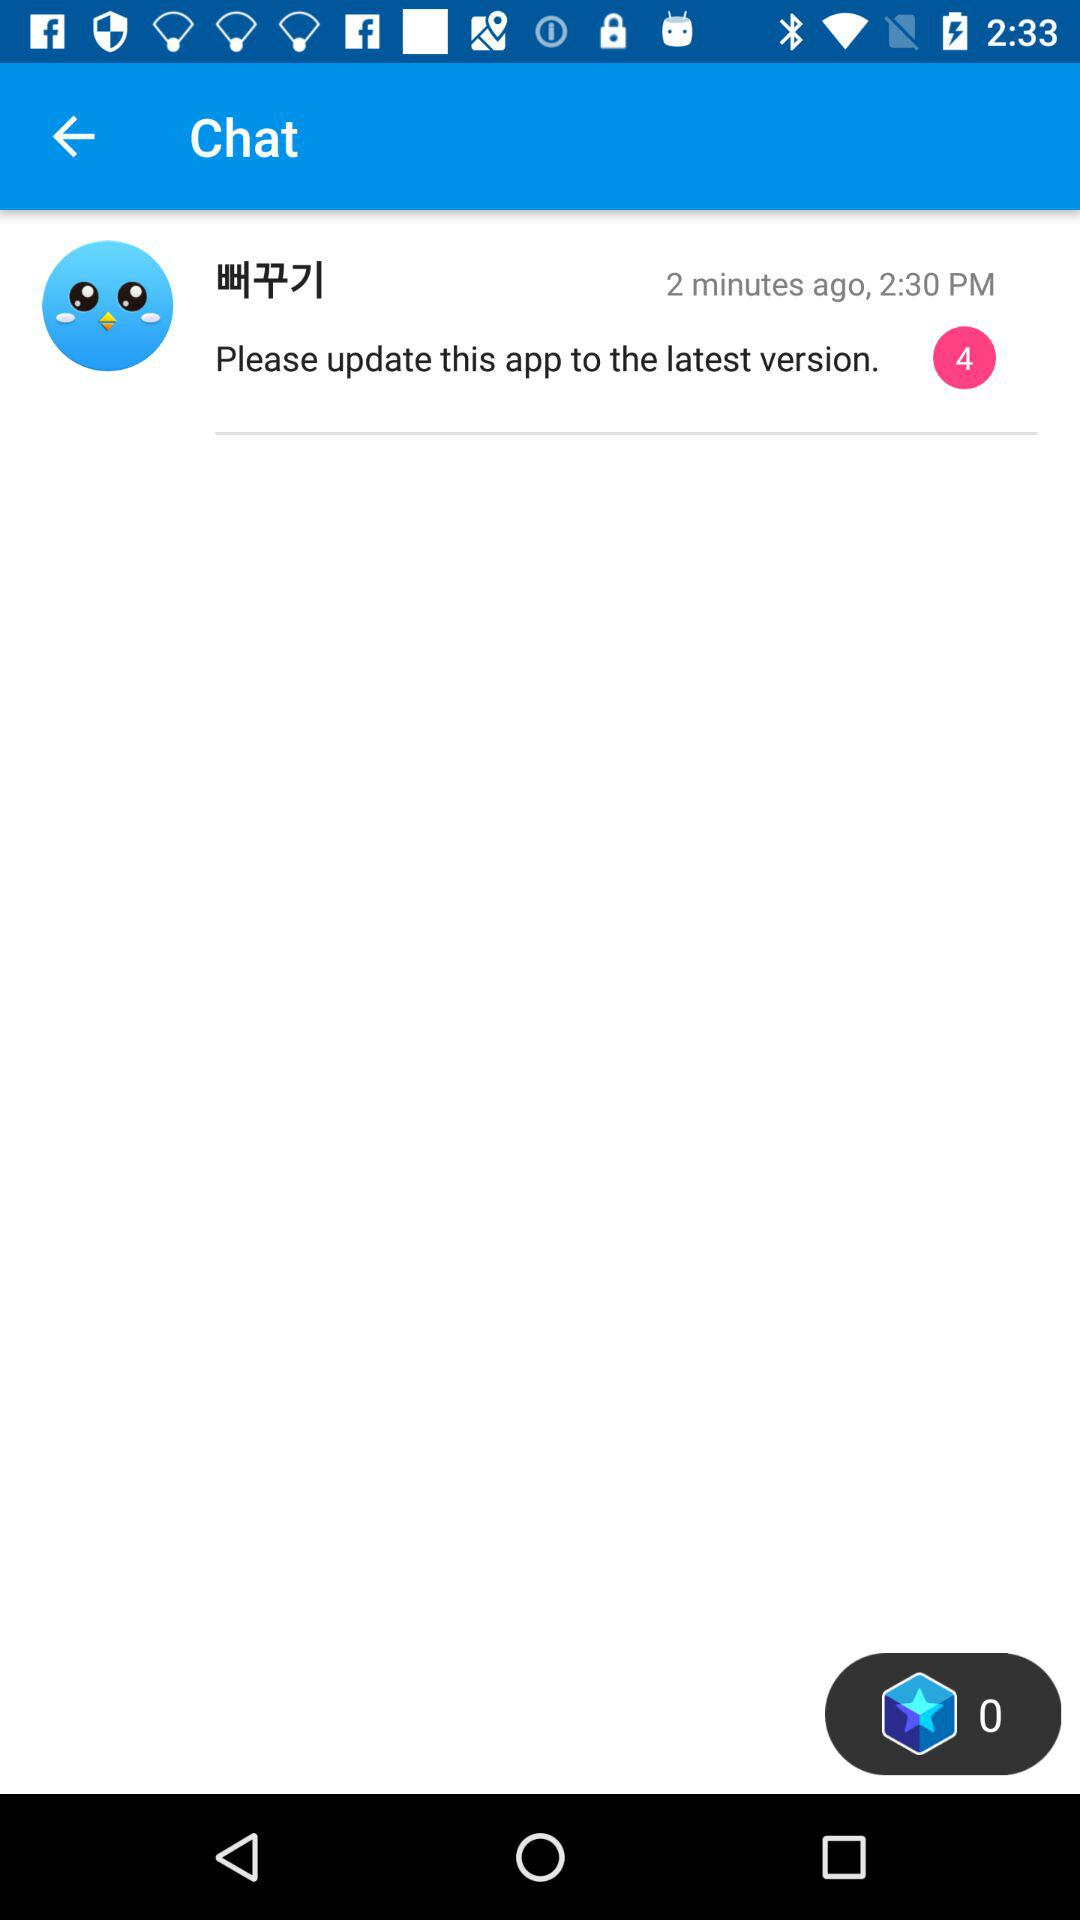When did the last message come? The last message came 2 minutes ago at 2:30 pm. 